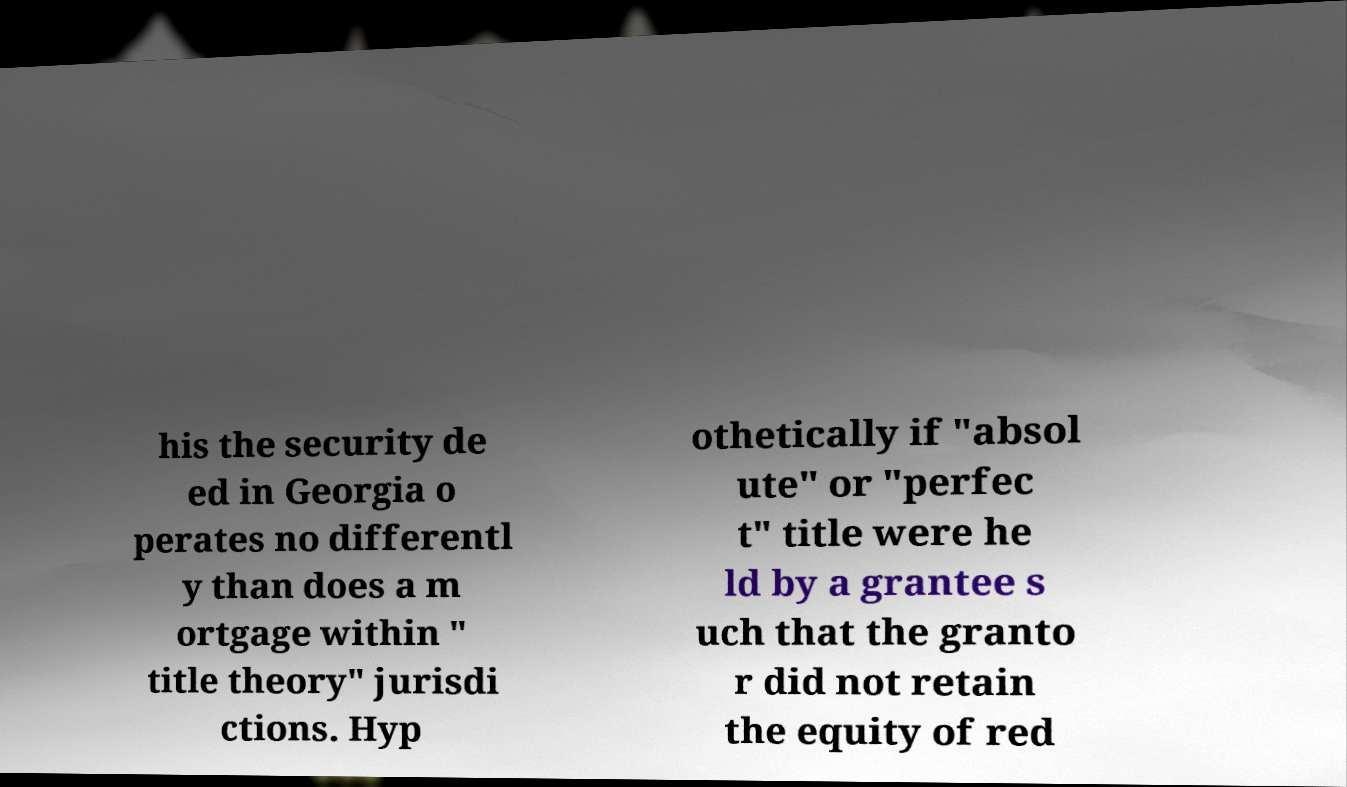Please read and relay the text visible in this image. What does it say? his the security de ed in Georgia o perates no differentl y than does a m ortgage within " title theory" jurisdi ctions. Hyp othetically if "absol ute" or "perfec t" title were he ld by a grantee s uch that the granto r did not retain the equity of red 